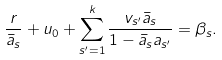Convert formula to latex. <formula><loc_0><loc_0><loc_500><loc_500>\frac { r } { \bar { a } _ { s } } + u _ { 0 } + \sum _ { s ^ { \prime } = 1 } ^ { k } \frac { v _ { s ^ { \prime } } \bar { a } _ { s } } { 1 - \bar { a } _ { s } a _ { s ^ { \prime } } } = \beta _ { s } .</formula> 